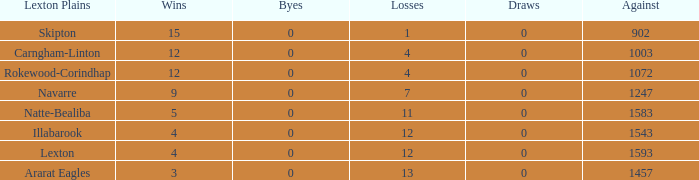What is the highest number of wins without any byes? None. 